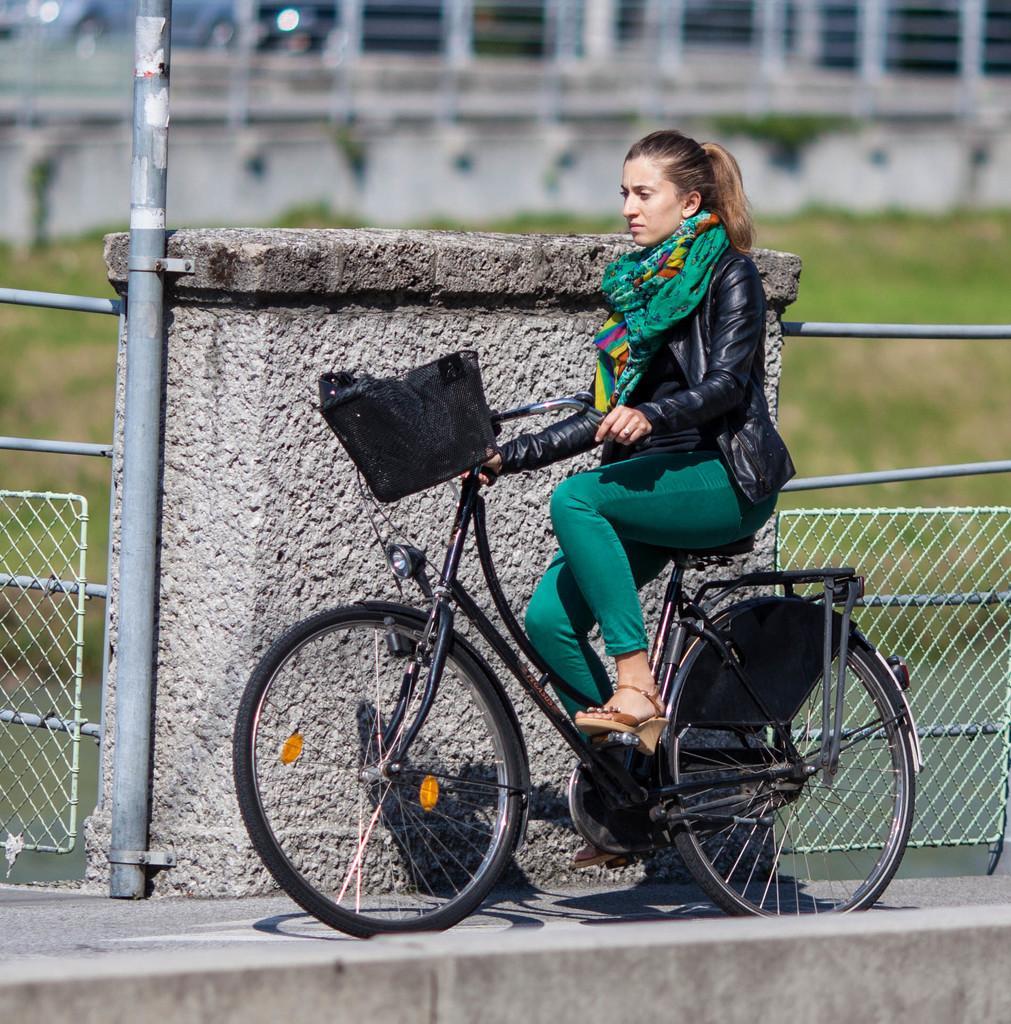In one or two sentences, can you explain what this image depicts? This image shows the girl who is riding the bicycle. At the background there is a wall and fencing. To the right side there is a grass at the background. 